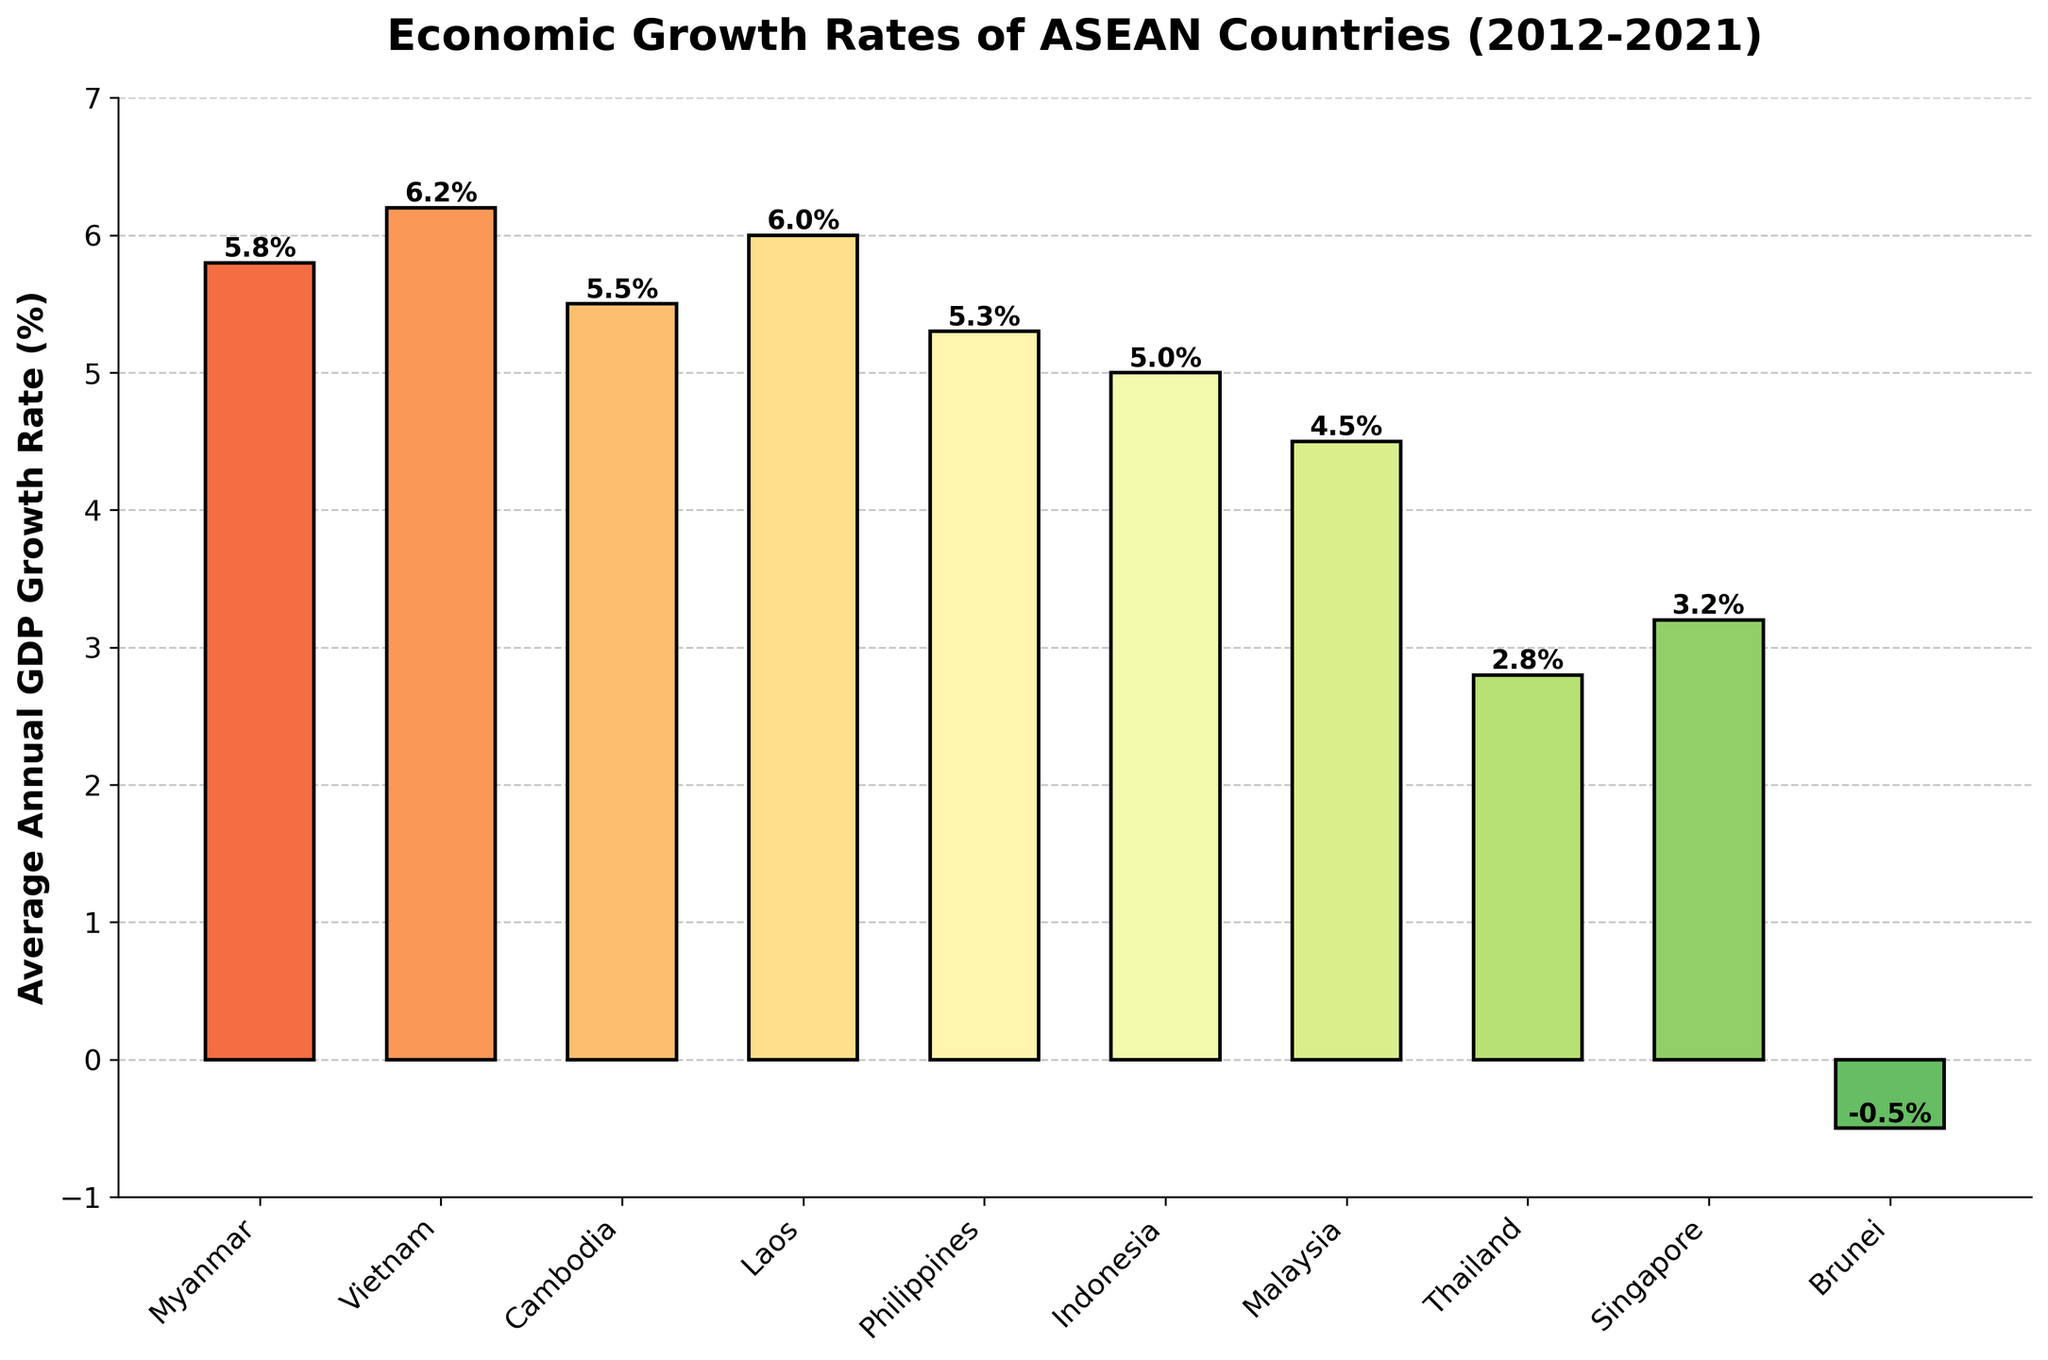What is the average annual GDP growth rate of Myanmar from 2012 to 2021? The figure shows the average annual GDP growth rates for each ASEAN country from 2012 to 2021. By locating Myanmar in the figure, we can see the exact growth rate.
Answer: 5.8% Which country has the highest average annual GDP growth rate between 2012 and 2021? By comparing the heights of the bars, we can identify that the tallest bar represents the country with the highest growth rate. Vietnam has the tallest bar.
Answer: Vietnam Which country has the lowest average annual GDP growth rate between 2012 and 2021? Observing the shortest bar in the figure, we can identify that Brunei has the lowest growth rate, as its bar extends below the zero mark indicating negative growth.
Answer: Brunei How does the average annual GDP growth rate of Vietnam compare to that of Myanmar? To compare the two countries, we look at the heights of their respective bars. Vietnam's bar is taller than Myanmar's, indicating a higher growth rate.
Answer: Vietnam > Myanmar What is the combined average annual GDP growth rate of Cambodia and Laos from 2012 to 2021? By locating and reading the heights of the bars for Cambodia and Laos, we then add their values together. Cambodia has 5.5% and Laos has 6.0%. So, 5.5% + 6.0% = 11.5%.
Answer: 11.5% Which countries have an average annual GDP growth rate higher than 5.0% from 2012 to 2021? We need to identify and list countries with bars that extend above the 5.0% mark. Vietnam, Myanmar, Laos, and Cambodia all have growth rates higher than 5.0%.
Answer: Vietnam, Myanmar, Laos, Cambodia By how much does Singapore's average annual GDP growth rate exceed Thailand's for the given period? We subtract Thailand's growth rate from Singapore's growth rate. Singapore has 3.2% and Thailand has 2.8%. So, 3.2% - 2.8% = 0.4%.
Answer: 0.4% If we consider the average annual GDP growth rate of Indonesia, Malaysia, and the Philippines, what is their combined rate? Summing the given values, Indonesia has 5.0%, Malaysia has 4.5%, and the Philippines has 5.3%, totaling 5.0% + 4.5% + 5.3% = 14.8%.
Answer: 14.8% What is the color gradient trend observed in the figure for countries with higher GDP growth rates? Higher growth rates are represented by bars in green shades, while lower or negative growth rates transition into yellow and red shades.
Answer: Green for higher growth rates, yellow/red for lower What is the difference in average annual GDP growth rate between the highest and lowest ASEAN countries from 2012 to 2021? We subtract the lowest growth rate, which is Brunei’s -0.5%, from the highest, Vietnam’s 6.2%, resulting in 6.2% - (-0.5%) = 6.7%.
Answer: 6.7% 